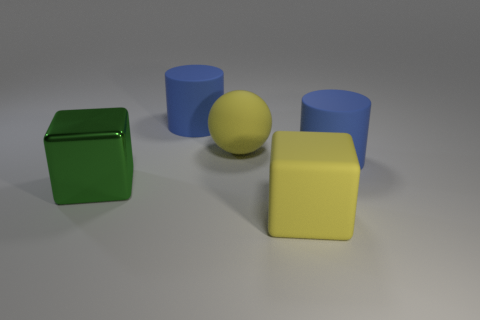What is the material of the big yellow ball?
Provide a short and direct response. Rubber. What size is the green thing?
Provide a succinct answer. Large. There is a thing that is behind the large green shiny cube and left of the large matte ball; what is its size?
Provide a short and direct response. Large. What is the shape of the matte object that is in front of the big green cube?
Your answer should be compact. Cube. Is the big yellow cube made of the same material as the blue object on the right side of the yellow cube?
Ensure brevity in your answer.  Yes. There is another large object that is the same shape as the green object; what is its material?
Offer a terse response. Rubber. What is the color of the object that is both left of the big yellow ball and behind the big green metallic thing?
Give a very brief answer. Blue. The large rubber sphere has what color?
Your answer should be compact. Yellow. What is the material of the thing that is the same color as the matte cube?
Your response must be concise. Rubber. Is there another large yellow thing that has the same shape as the metallic object?
Keep it short and to the point. Yes. 